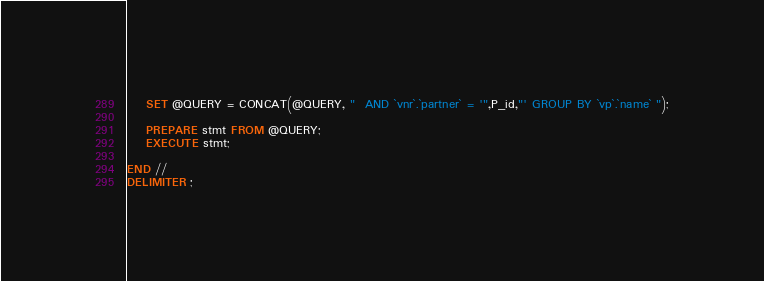Convert code to text. <code><loc_0><loc_0><loc_500><loc_500><_SQL_>
    SET @QUERY = CONCAT(@QUERY, "  AND `vnr`.`partner` = '",P_id,"' GROUP BY `vp`.`name` ");

    PREPARE stmt FROM @QUERY;
    EXECUTE stmt;
    
END //
DELIMITER ;
</code> 